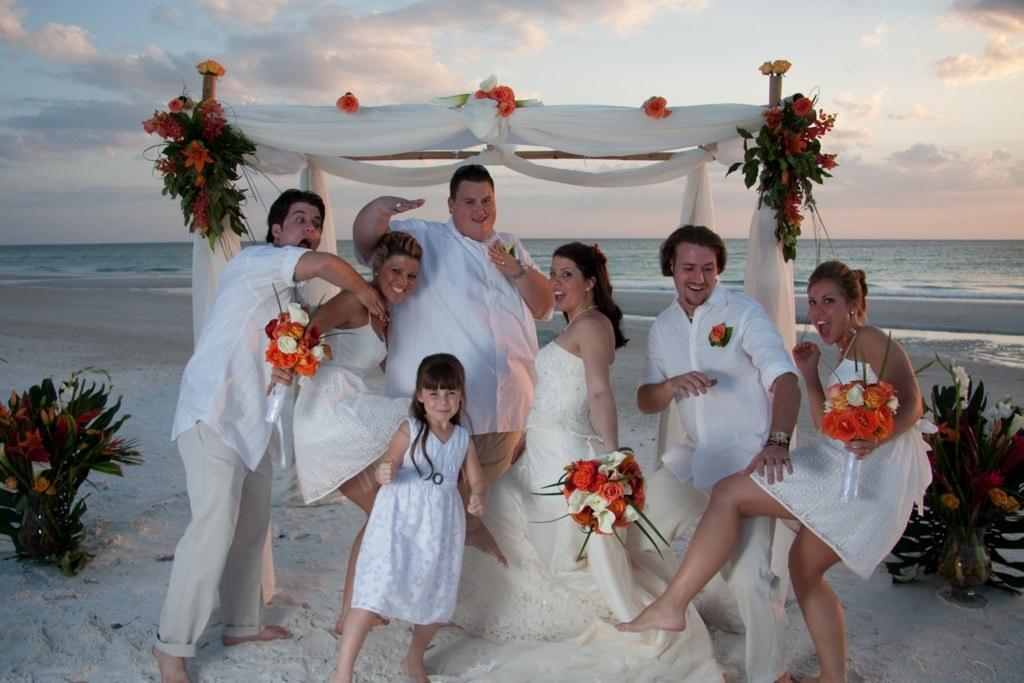Who or what is present in the image? There are people in the image. Where are the people located? The people are on the seashore. What are some of the people holding in their hands? Some people are holding flowers in their hands. What type of industry can be seen in the background of the image? There is no industry visible in the background of the image; it features of the seashore are present instead. 